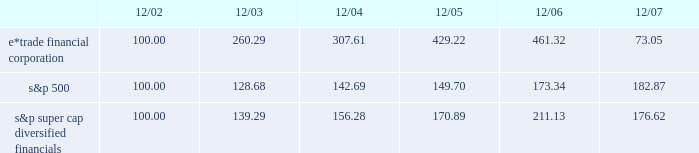December 18 , 2007 , we issued an additional 23182197 shares of common stock to citadel .
The issuances were exempt from registration pursuant to section 4 ( 2 ) of the securities act of 1933 , and each purchaser has represented to us that it is an 201caccredited investor 201d as defined in regulation d promulgated under the securities act of 1933 , and that the common stock was being acquired for investment .
We did not engage in a general solicitation or advertising with regard to the issuances of the common stock and have not offered securities to the public in connection with the issuances .
See item 1 .
Business 2014citadel investment .
Performance graph the following performance graph shows the cumulative total return to a holder of the company 2019s common stock , assuming dividend reinvestment , compared with the cumulative total return , assuming dividend reinvestment , of the standard & poor 2019s ( 201cs&p 201d ) 500 and the s&p super cap diversified financials during the period from december 31 , 2002 through december 31 , 2007. .
2022 $ 100 invested on 12/31/02 in stock or index-including reinvestment of dividends .
Fiscal year ending december 31 .
2022 copyright a9 2008 , standard & poor 2019s , a division of the mcgraw-hill companies , inc .
All rights reserved .
Www.researchdatagroup.com/s&p.htm .
As of december 2007 what was the ratio of the ratio of the cumulative total return for s&p 500 to the e*trade financial corporation? 
Rationale: as of december 2007 there was 2.5 times the amount of returns for the s&p 500 to the e*trade financial corporation
Computations: (182.87 / 73.05)
Answer: 2.50335. 